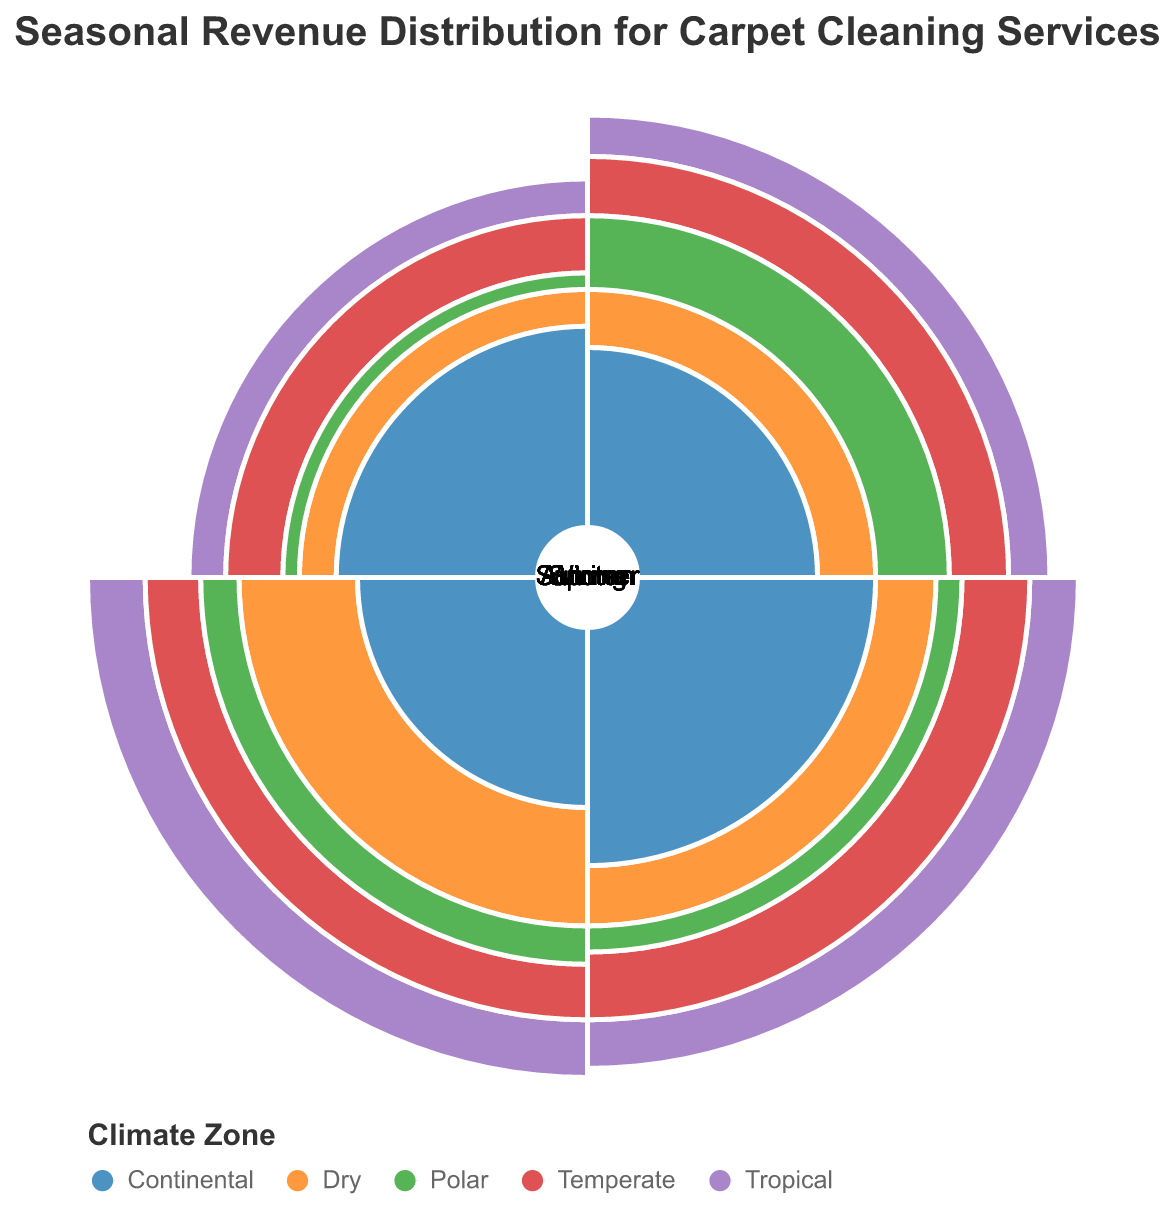What is the title of the chart? The title of the chart is displayed at the top in bold and larger font size. It reads "Seasonal Revenue Distribution for Carpet Cleaning Services."
Answer: Seasonal Revenue Distribution for Carpet Cleaning Services Which climate zone shows the highest revenue during Winter? To determine this, look at the arc segments corresponding to "Winter" for each climate zone and observe which one extends furthest from the center. The "Continental" zone has the largest segment in Winter.
Answer: Continental How does the revenue in Summer for the Temperate zone compare to that in Spring for the same zone? Note the radius of the arc segments for "Summer" and "Spring" within the "Temperate" zone. The segment for Spring is slightly larger than that for Summer.
Answer: Spring is higher Which season shows the lowest revenue for the Polar zone? From the figure, locate the arc segments of the Polar zone and compare their radial lengths. The Winter season has the smallest arc length.
Answer: Winter Which climate zone has the most balanced revenue distribution across all seasons? Examine the arc segments for each climate zone to see which has the most similar lengths across Winter, Spring, Summer, and Autumn. The Temperate zone’s arcs are more evenly distributed.
Answer: Temperate Between Summer and Autumn, which season contributes more to the revenue in the Dry climate zone? Observe the lengths of the arc segments for Summer and Autumn within the Dry zone. The Summer segment is considerably longer.
Answer: Summer What is the combined revenue for the Continental zone in Spring and Autumn? Summing the arc lengths for the "Continental" zone in Spring (35) and Autumn (20) gives a combined value of 55.
Answer: 55 Which season generates the highest revenue across all climate zones? By comparing the maximum arc extent for each season across all zones, Spring emerges as the most frequent peak.
Answer: Spring In which season does the Tropical zone have its highest revenue? Look for the longest arc segment within the Tropical zone. The longest arc is in Summer.
Answer: Summer How does the Polar zone’s Autumn revenue compare to its Spring revenue? Comparing the arc lengths for Autumn (25) and Spring (10) within the Polar zone, Autumn’s revenue is higher.
Answer: Autumn is higher 